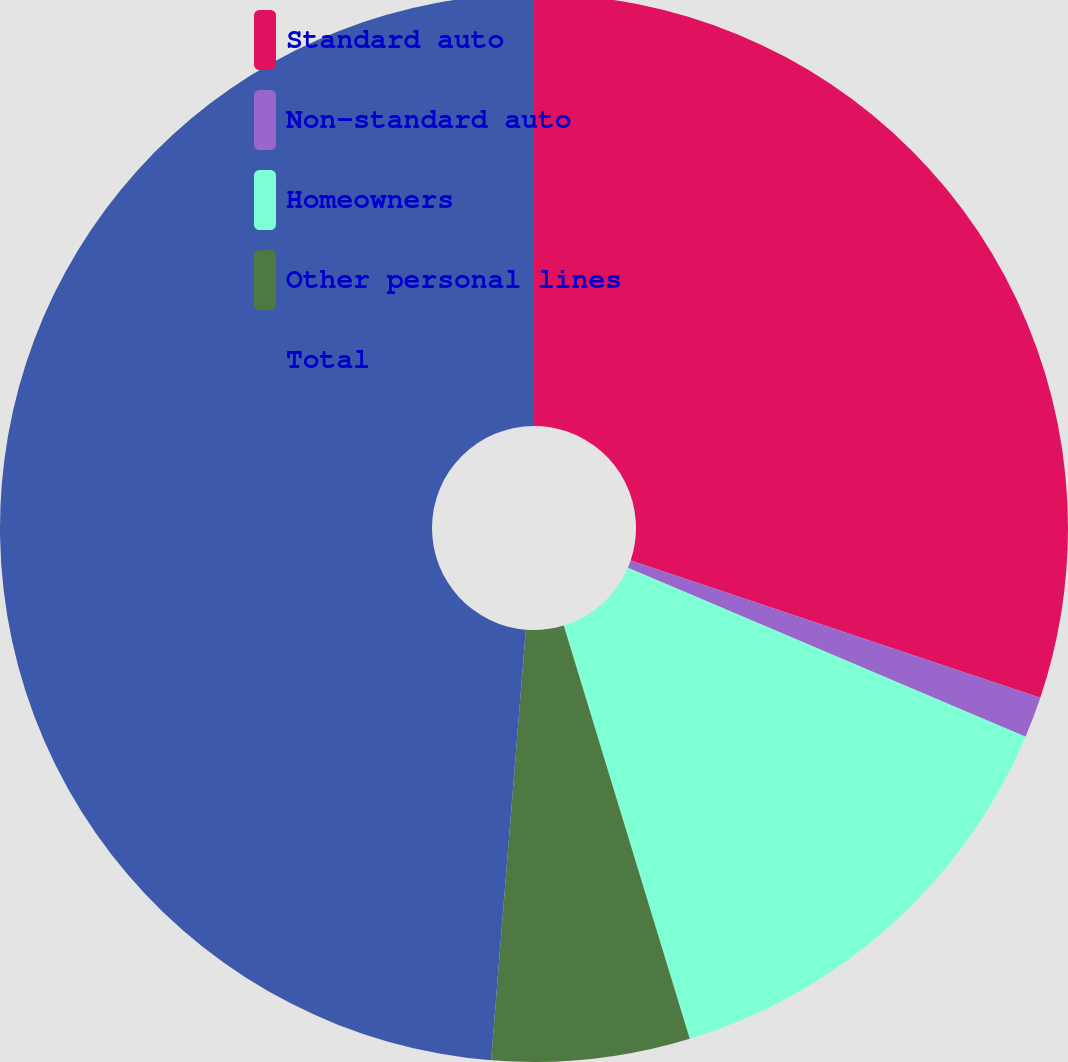<chart> <loc_0><loc_0><loc_500><loc_500><pie_chart><fcel>Standard auto<fcel>Non-standard auto<fcel>Homeowners<fcel>Other personal lines<fcel>Total<nl><fcel>30.15%<fcel>1.24%<fcel>13.9%<fcel>5.99%<fcel>48.72%<nl></chart> 